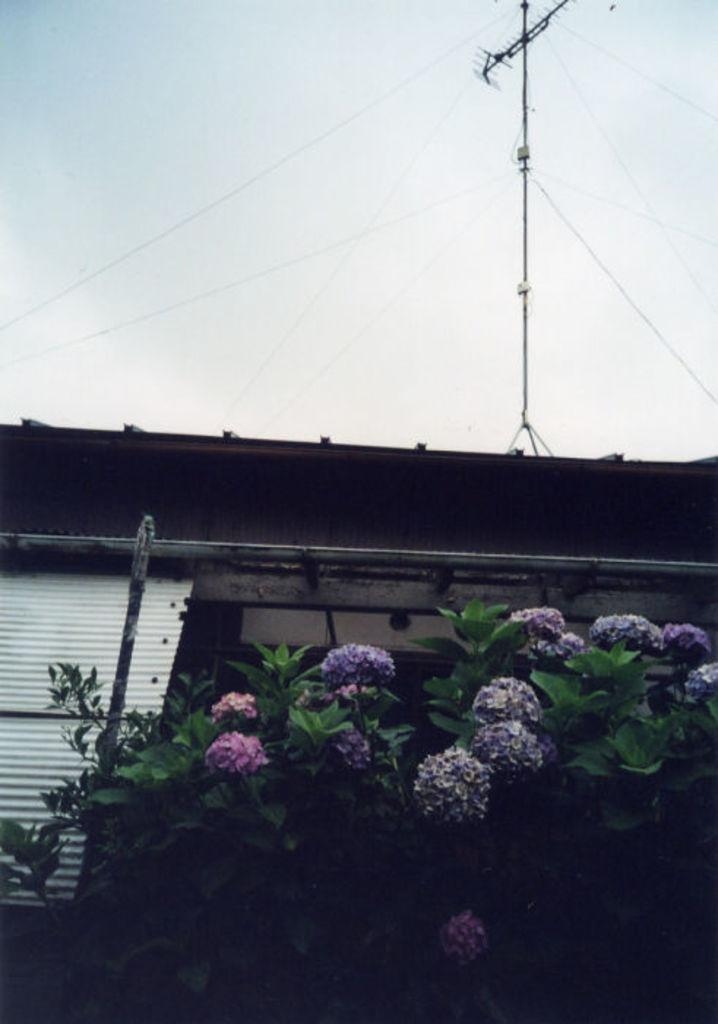What colors are the flowers in the image? The flowers in the image are in purple and pink colors. What color are the plants in the image? The plants in the image are in green color. What color is the shed in the image? The shed in the image is in white color. What can be seen in the background of the image? There is a current pole in the background of the image. What is visible in the sky in the image? A: The sky is visible in the image, and it appears to be white. How does the cast help the flowers grow in the image? There is no cast present in the image, and therefore it cannot help the flowers grow. 